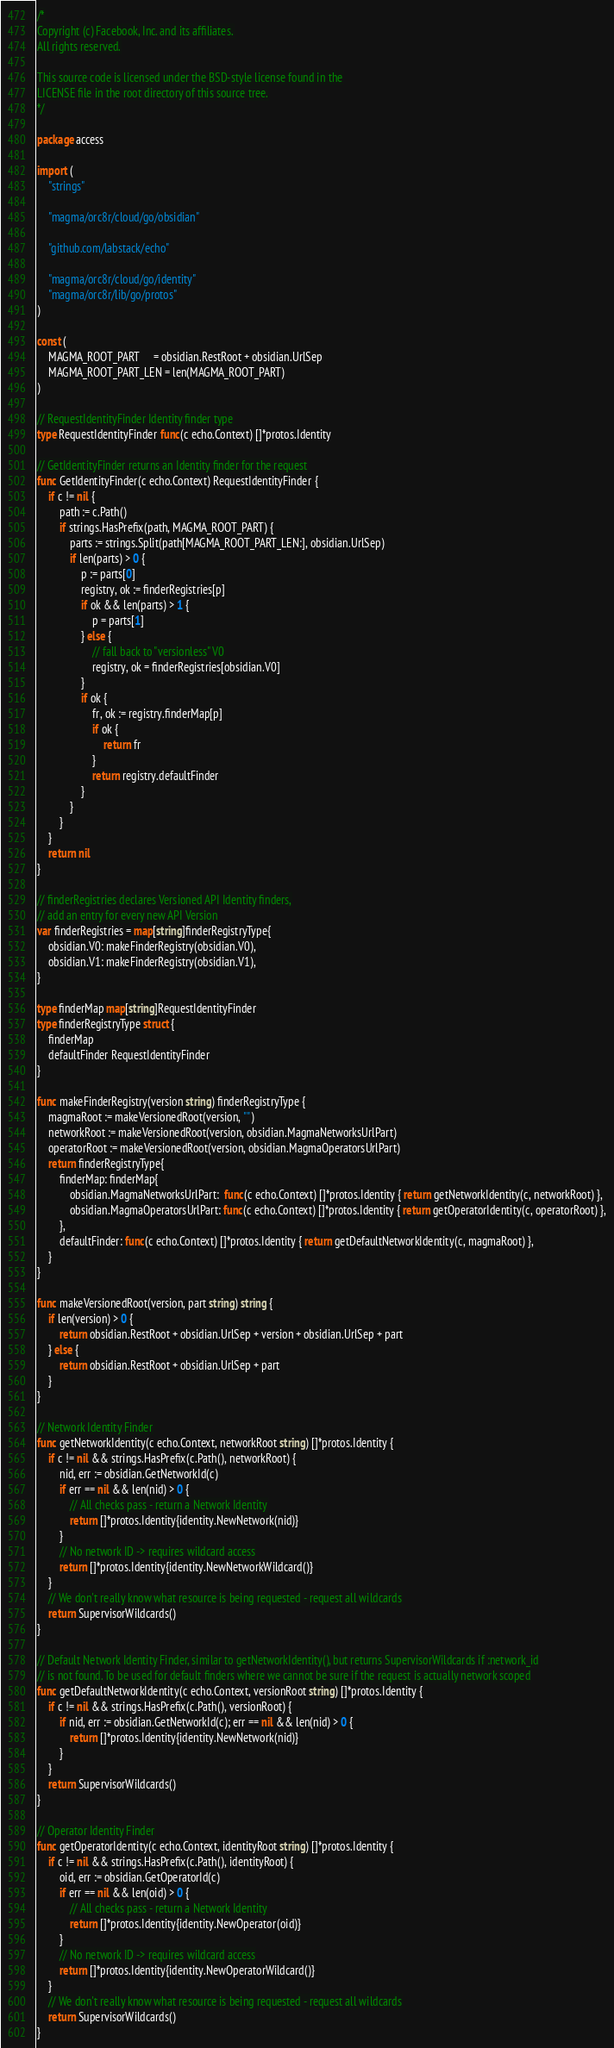Convert code to text. <code><loc_0><loc_0><loc_500><loc_500><_Go_>/*
Copyright (c) Facebook, Inc. and its affiliates.
All rights reserved.

This source code is licensed under the BSD-style license found in the
LICENSE file in the root directory of this source tree.
*/

package access

import (
	"strings"

	"magma/orc8r/cloud/go/obsidian"

	"github.com/labstack/echo"

	"magma/orc8r/cloud/go/identity"
	"magma/orc8r/lib/go/protos"
)

const (
	MAGMA_ROOT_PART     = obsidian.RestRoot + obsidian.UrlSep
	MAGMA_ROOT_PART_LEN = len(MAGMA_ROOT_PART)
)

// RequestIdentityFinder Identity finder type
type RequestIdentityFinder func(c echo.Context) []*protos.Identity

// GetIdentityFinder returns an Identity finder for the request
func GetIdentityFinder(c echo.Context) RequestIdentityFinder {
	if c != nil {
		path := c.Path()
		if strings.HasPrefix(path, MAGMA_ROOT_PART) {
			parts := strings.Split(path[MAGMA_ROOT_PART_LEN:], obsidian.UrlSep)
			if len(parts) > 0 {
				p := parts[0]
				registry, ok := finderRegistries[p]
				if ok && len(parts) > 1 {
					p = parts[1]
				} else {
					// fall back to "versionless" V0
					registry, ok = finderRegistries[obsidian.V0]
				}
				if ok {
					fr, ok := registry.finderMap[p]
					if ok {
						return fr
					}
					return registry.defaultFinder
				}
			}
		}
	}
	return nil
}

// finderRegistries declares Versioned API Identity finders,
// add an entry for every new API Version
var finderRegistries = map[string]finderRegistryType{
	obsidian.V0: makeFinderRegistry(obsidian.V0),
	obsidian.V1: makeFinderRegistry(obsidian.V1),
}

type finderMap map[string]RequestIdentityFinder
type finderRegistryType struct {
	finderMap
	defaultFinder RequestIdentityFinder
}

func makeFinderRegistry(version string) finderRegistryType {
	magmaRoot := makeVersionedRoot(version, "")
	networkRoot := makeVersionedRoot(version, obsidian.MagmaNetworksUrlPart)
	operatorRoot := makeVersionedRoot(version, obsidian.MagmaOperatorsUrlPart)
	return finderRegistryType{
		finderMap: finderMap{
			obsidian.MagmaNetworksUrlPart:  func(c echo.Context) []*protos.Identity { return getNetworkIdentity(c, networkRoot) },
			obsidian.MagmaOperatorsUrlPart: func(c echo.Context) []*protos.Identity { return getOperatorIdentity(c, operatorRoot) },
		},
		defaultFinder: func(c echo.Context) []*protos.Identity { return getDefaultNetworkIdentity(c, magmaRoot) },
	}
}

func makeVersionedRoot(version, part string) string {
	if len(version) > 0 {
		return obsidian.RestRoot + obsidian.UrlSep + version + obsidian.UrlSep + part
	} else {
		return obsidian.RestRoot + obsidian.UrlSep + part
	}
}

// Network Identity Finder
func getNetworkIdentity(c echo.Context, networkRoot string) []*protos.Identity {
	if c != nil && strings.HasPrefix(c.Path(), networkRoot) {
		nid, err := obsidian.GetNetworkId(c)
		if err == nil && len(nid) > 0 {
			// All checks pass - return a Network Identity
			return []*protos.Identity{identity.NewNetwork(nid)}
		}
		// No network ID -> requires wildcard access
		return []*protos.Identity{identity.NewNetworkWildcard()}
	}
	// We don't really know what resource is being requested - request all wildcards
	return SupervisorWildcards()
}

// Default Network Identity Finder, similar to getNetworkIdentity(), but returns SupervisorWildcards if :network_id
// is not found. To be used for default finders where we cannot be sure if the request is actually network scoped
func getDefaultNetworkIdentity(c echo.Context, versionRoot string) []*protos.Identity {
	if c != nil && strings.HasPrefix(c.Path(), versionRoot) {
		if nid, err := obsidian.GetNetworkId(c); err == nil && len(nid) > 0 {
			return []*protos.Identity{identity.NewNetwork(nid)}
		}
	}
	return SupervisorWildcards()
}

// Operator Identity Finder
func getOperatorIdentity(c echo.Context, identityRoot string) []*protos.Identity {
	if c != nil && strings.HasPrefix(c.Path(), identityRoot) {
		oid, err := obsidian.GetOperatorId(c)
		if err == nil && len(oid) > 0 {
			// All checks pass - return a Network Identity
			return []*protos.Identity{identity.NewOperator(oid)}
		}
		// No network ID -> requires wildcard access
		return []*protos.Identity{identity.NewOperatorWildcard()}
	}
	// We don't really know what resource is being requested - request all wildcards
	return SupervisorWildcards()
}
</code> 